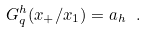<formula> <loc_0><loc_0><loc_500><loc_500>G _ { q } ^ { h } ( x _ { + } / x _ { 1 } ) = a _ { h } \ .</formula> 